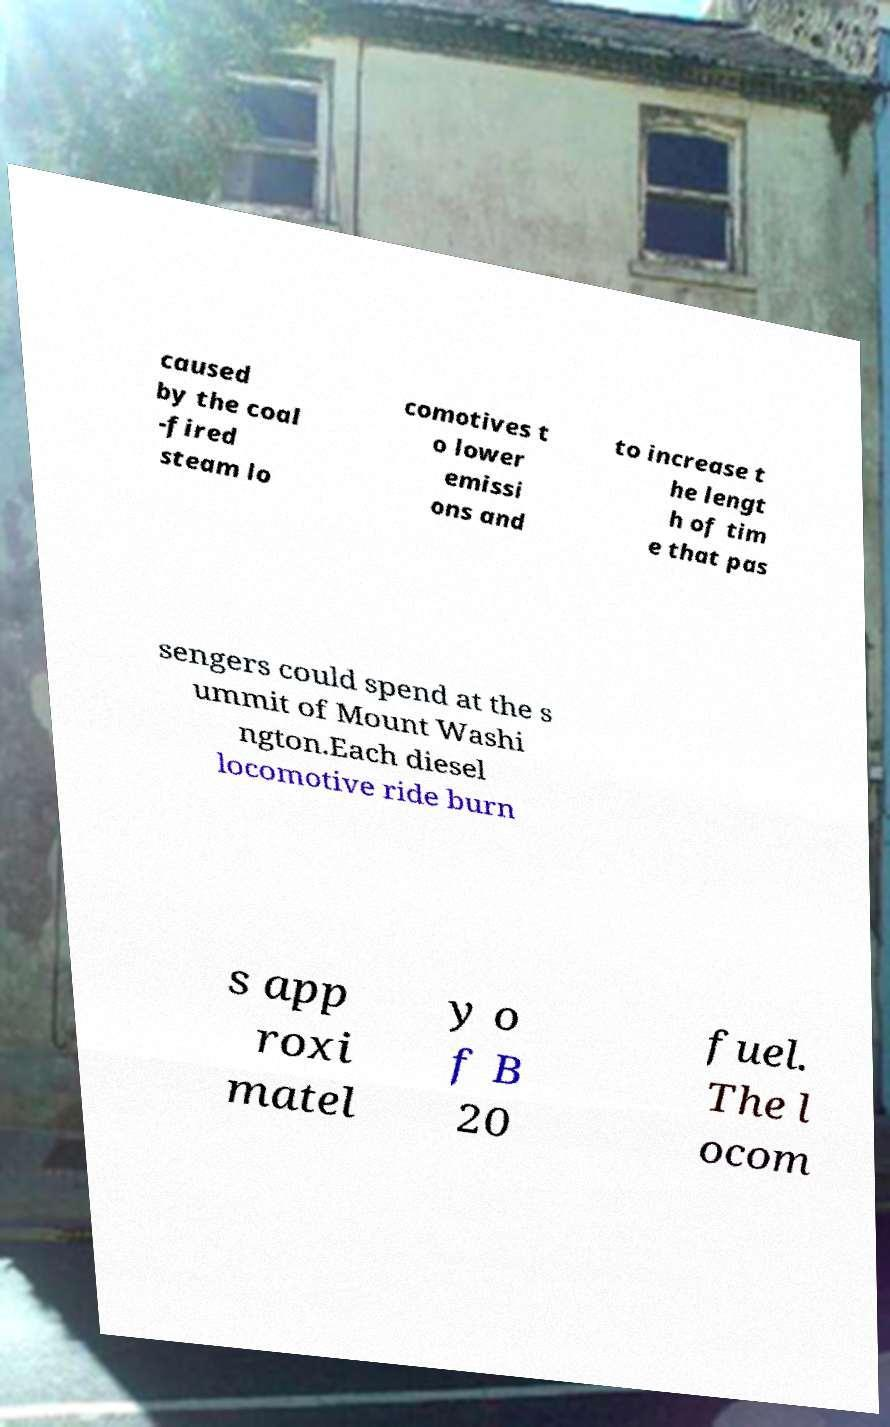Please identify and transcribe the text found in this image. caused by the coal -fired steam lo comotives t o lower emissi ons and to increase t he lengt h of tim e that pas sengers could spend at the s ummit of Mount Washi ngton.Each diesel locomotive ride burn s app roxi matel y o f B 20 fuel. The l ocom 